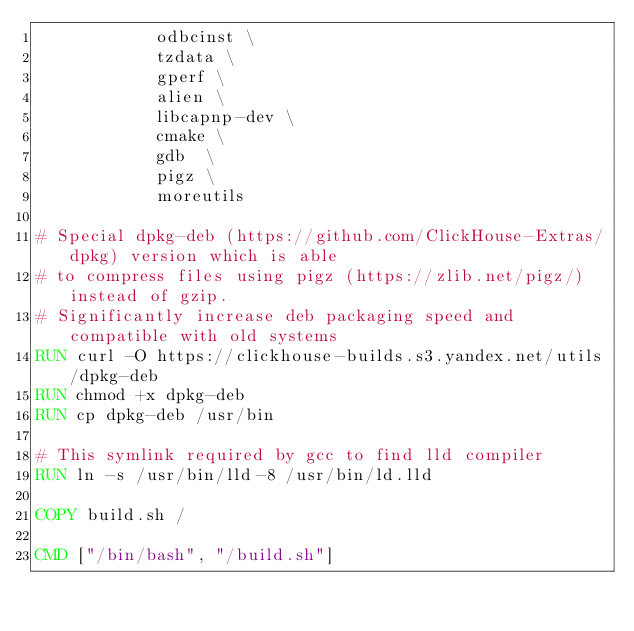Convert code to text. <code><loc_0><loc_0><loc_500><loc_500><_Dockerfile_>            odbcinst \
            tzdata \
            gperf \
            alien \
            libcapnp-dev \
            cmake \
            gdb  \
            pigz \
            moreutils

# Special dpkg-deb (https://github.com/ClickHouse-Extras/dpkg) version which is able
# to compress files using pigz (https://zlib.net/pigz/) instead of gzip.
# Significantly increase deb packaging speed and compatible with old systems
RUN curl -O https://clickhouse-builds.s3.yandex.net/utils/dpkg-deb
RUN chmod +x dpkg-deb
RUN cp dpkg-deb /usr/bin

# This symlink required by gcc to find lld compiler
RUN ln -s /usr/bin/lld-8 /usr/bin/ld.lld

COPY build.sh /

CMD ["/bin/bash", "/build.sh"]
</code> 